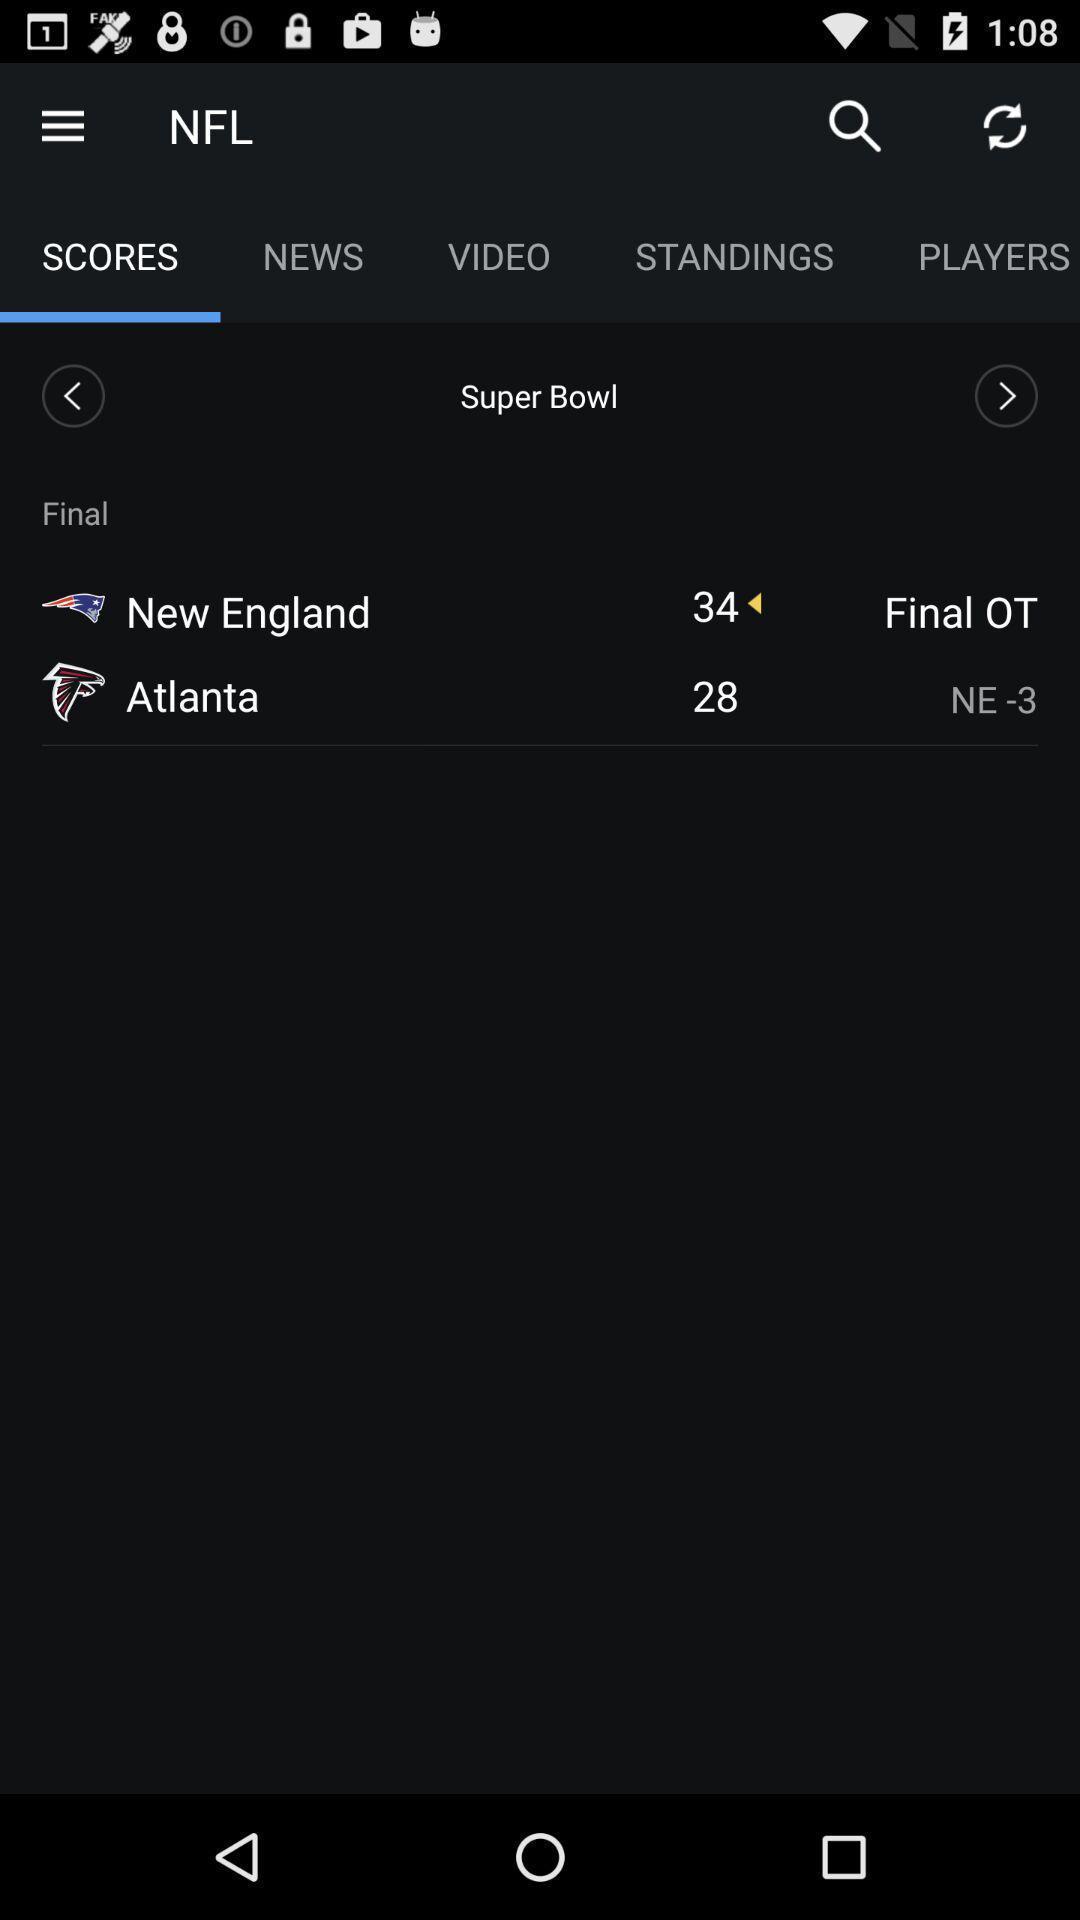Summarize the information in this screenshot. Screen page of a sports application. 